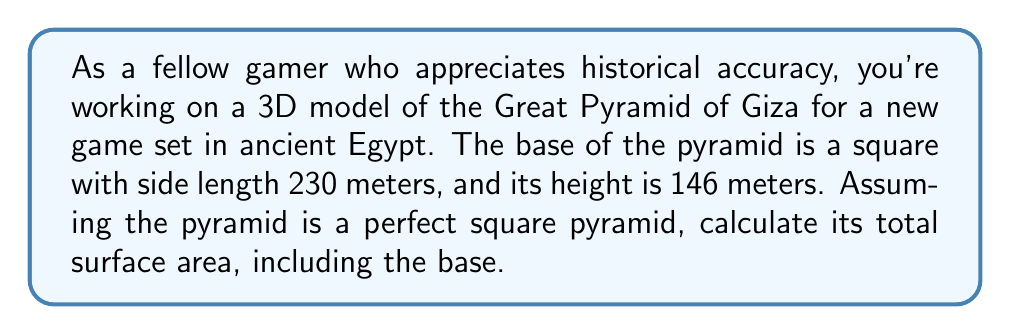Solve this math problem. To calculate the surface area of a square pyramid, we need to find the area of the base and the area of the four triangular faces, then sum them up.

1. Area of the base:
   The base is a square, so its area is given by $A_{base} = s^2$, where $s$ is the side length.
   $A_{base} = 230^2 = 52,900 \text{ m}^2$

2. Area of a triangular face:
   To find this, we need the slant height of the pyramid. We can calculate this using the Pythagorean theorem:

   $$l^2 = (\frac{s}{2})^2 + h^2$$

   Where $l$ is the slant height, $s$ is the side length of the base, and $h$ is the height of the pyramid.

   $$l^2 = (\frac{230}{2})^2 + 146^2$$
   $$l^2 = 115^2 + 146^2 = 13,225 + 21,316 = 34,541$$
   $$l = \sqrt{34,541} \approx 185.85 \text{ m}$$

   The area of each triangular face is then:
   $$A_{face} = \frac{1}{2} \cdot 230 \cdot 185.85 = 21,372.75 \text{ m}^2$$

3. Total surface area:
   Sum the base area and the areas of the four triangular faces:
   $$A_{total} = A_{base} + 4 \cdot A_{face}$$
   $$A_{total} = 52,900 + 4 \cdot 21,372.75 = 52,900 + 85,491 = 138,391 \text{ m}^2$$

[asy]
import geometry;

size(200);
pair A = (0,0), B = (4,0), C = (2,3);
draw(A--B--C--cycle);
draw(A--(-1,0), arrow=Arrow());
draw(B--(5,0), arrow=Arrow());
label("230 m", (2,-0.3));
draw((2,0)--(2,3), dashed);
label("146 m", (2.3,1.5), E);
draw((0,0)--(2,3), blue);
label("Slant height", (0.7,1.5), W);
[/asy]
Answer: The total surface area of the Great Pyramid of Giza model is approximately 138,391 square meters. 